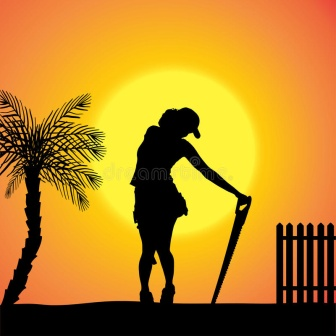Imagine a story that could be happening in this scene. In this serene scene, we see Amal, a gardener, taking a moment of rest at the end of a long day. As the sun sets, Amal reflects on the day’s achievements, having spent hours tending to a community garden that brings joy and fruitfulness to his village. The silhouette against the glowing sun symbolizes his tireless dedication and the quiet satisfaction he gains from his work. Each sunset marks not just an end, but a promise for a new beginning with the coming dawn, and with it, a renewed opportunity to cultivate life and beauty around him. 